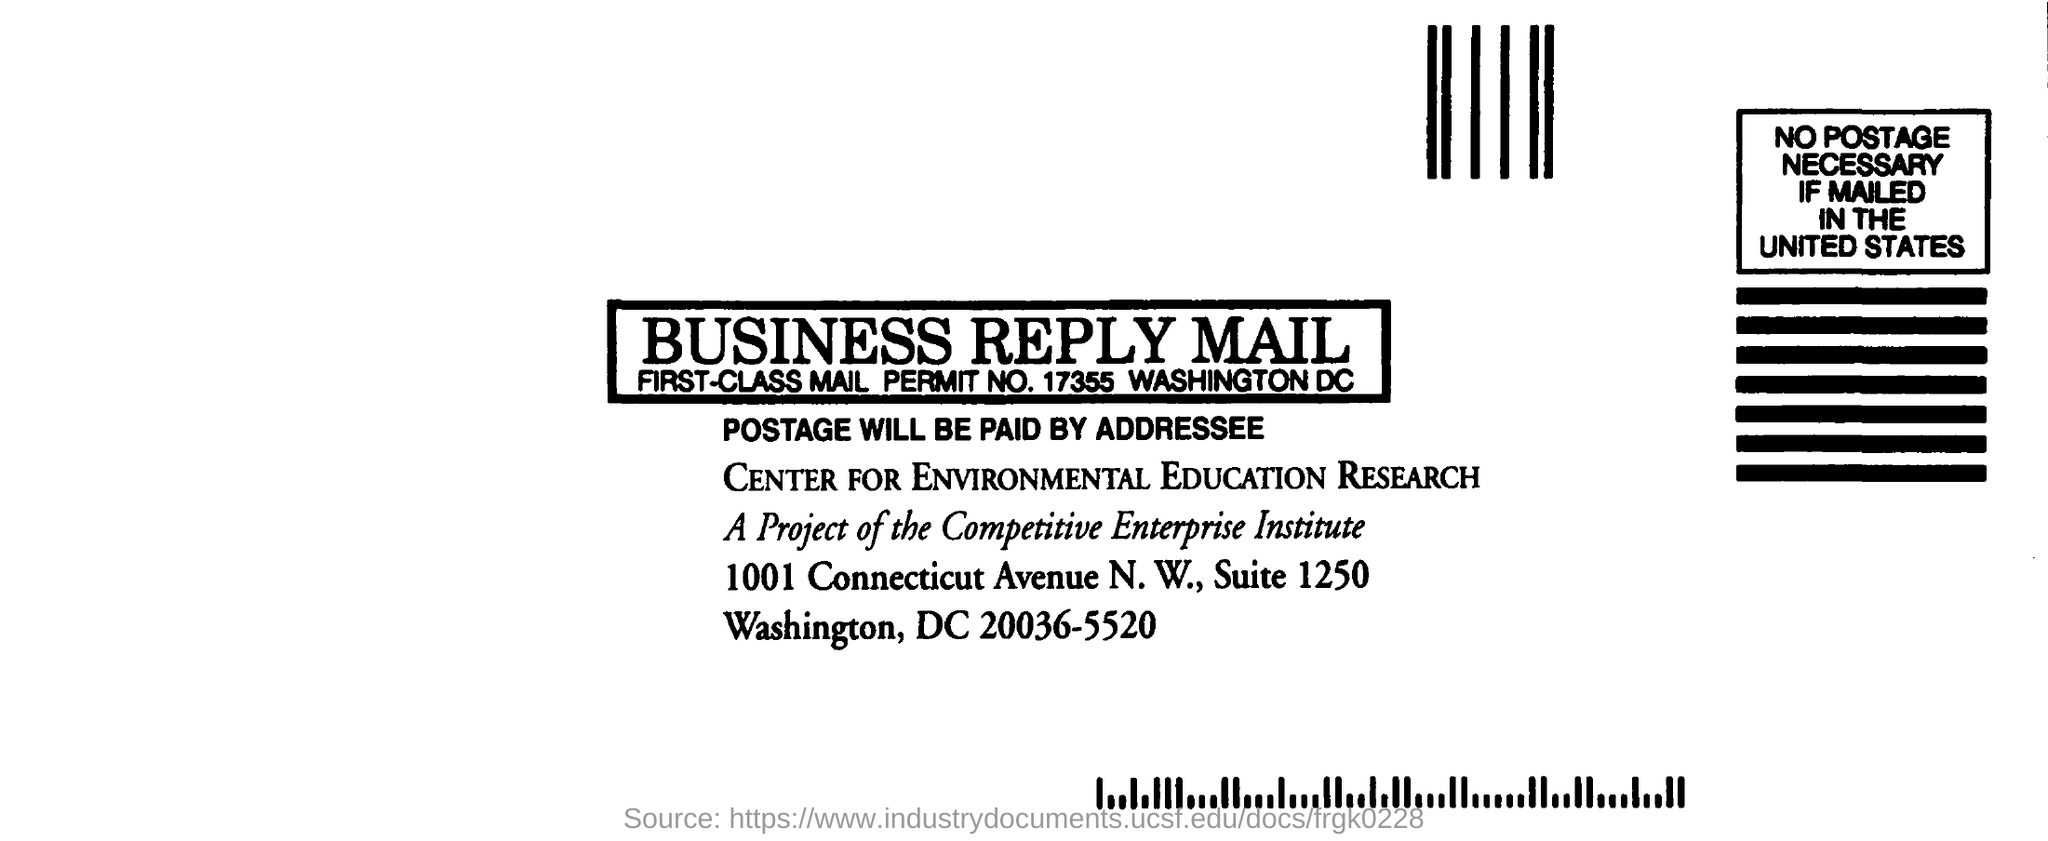What is the main title of the document?
Provide a short and direct response. Business Reply Mail. 